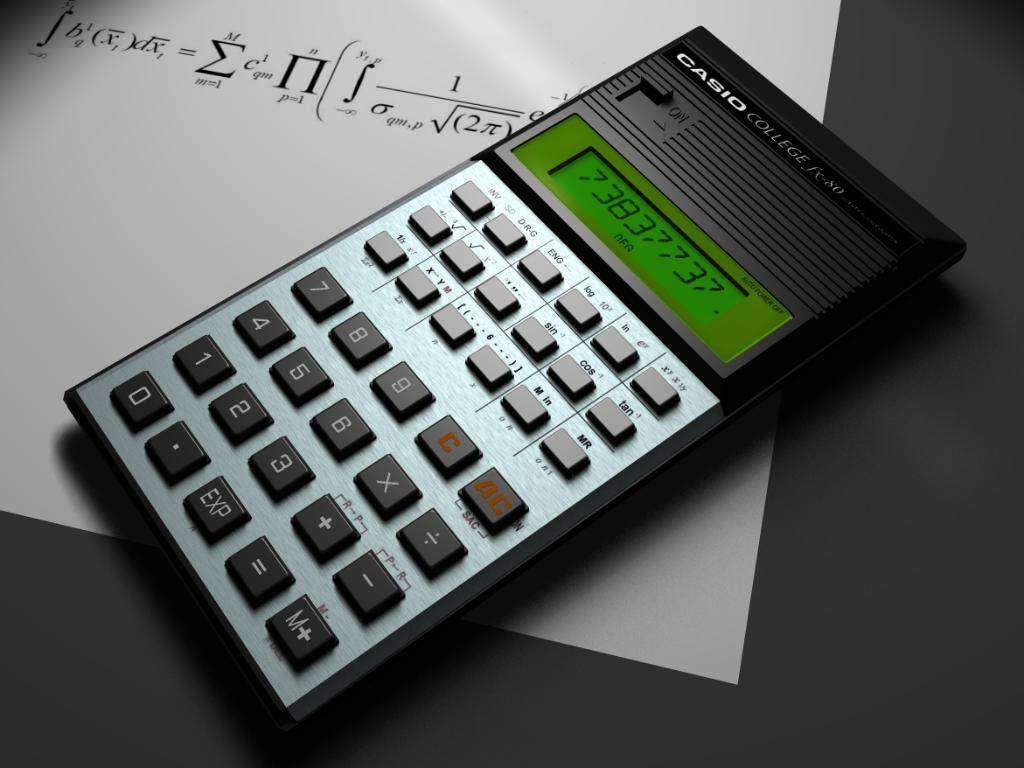Provide a one-sentence caption for the provided image. the number 0 is on the calculator with a gray background. 